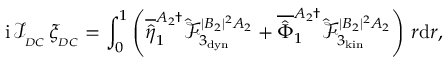<formula> <loc_0><loc_0><loc_500><loc_500>i \, \mathcal { I } _ { _ { D C } } \, \xi _ { _ { D C } } = \int _ { 0 } ^ { 1 } \left ( \overline { { \hat { \eta } } } _ { 1 } ^ { A _ { 2 } \dagger } \hat { \mathcal { F } } _ { 3 _ { d y n } } ^ { | B _ { 2 } | ^ { 2 } A _ { 2 } } + \overline { { \hat { \Phi } } } _ { 1 } ^ { A _ { 2 } \dagger } \hat { \mathcal { F } } _ { 3 _ { k i n } } ^ { | B _ { 2 } | ^ { 2 } A _ { 2 } } \right ) \, r d r ,</formula> 